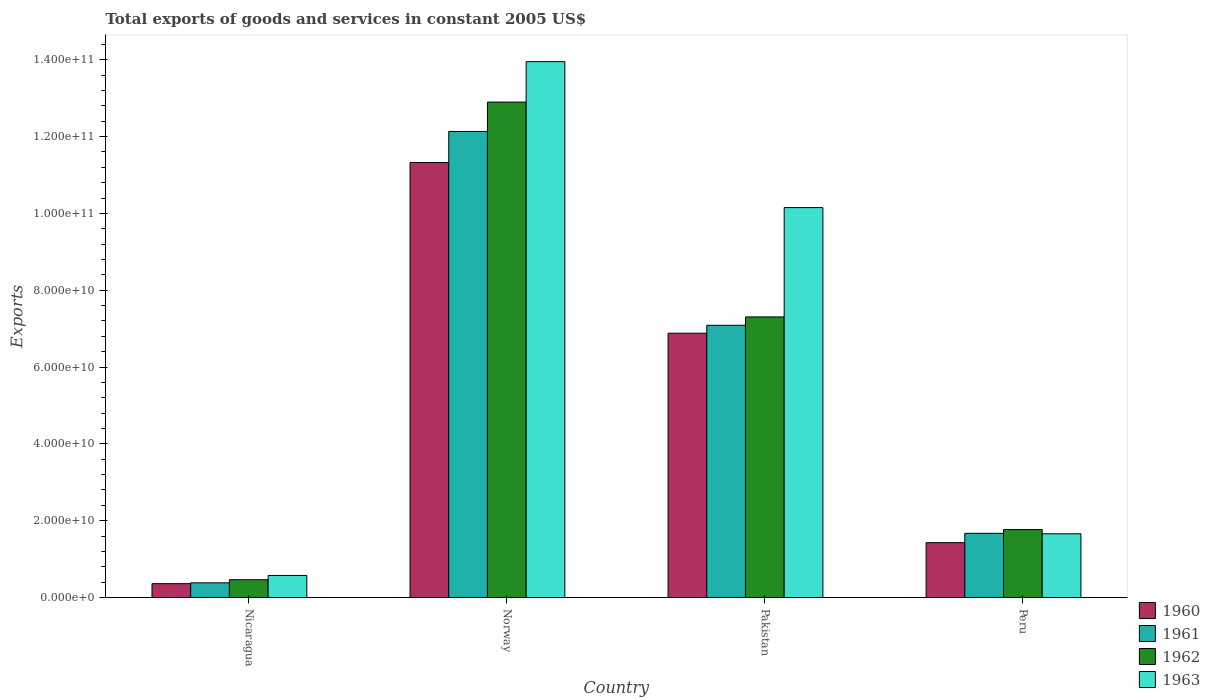How many different coloured bars are there?
Provide a succinct answer. 4. Are the number of bars on each tick of the X-axis equal?
Provide a succinct answer. Yes. How many bars are there on the 3rd tick from the left?
Offer a very short reply. 4. What is the label of the 1st group of bars from the left?
Ensure brevity in your answer.  Nicaragua. In how many cases, is the number of bars for a given country not equal to the number of legend labels?
Your response must be concise. 0. What is the total exports of goods and services in 1960 in Pakistan?
Offer a terse response. 6.88e+1. Across all countries, what is the maximum total exports of goods and services in 1960?
Offer a very short reply. 1.13e+11. Across all countries, what is the minimum total exports of goods and services in 1961?
Your answer should be very brief. 3.83e+09. In which country was the total exports of goods and services in 1963 maximum?
Your response must be concise. Norway. In which country was the total exports of goods and services in 1963 minimum?
Your answer should be compact. Nicaragua. What is the total total exports of goods and services in 1961 in the graph?
Provide a short and direct response. 2.13e+11. What is the difference between the total exports of goods and services in 1963 in Nicaragua and that in Norway?
Your answer should be compact. -1.34e+11. What is the difference between the total exports of goods and services in 1963 in Pakistan and the total exports of goods and services in 1961 in Peru?
Give a very brief answer. 8.48e+1. What is the average total exports of goods and services in 1963 per country?
Provide a short and direct response. 6.58e+1. What is the difference between the total exports of goods and services of/in 1962 and total exports of goods and services of/in 1963 in Pakistan?
Offer a very short reply. -2.85e+1. What is the ratio of the total exports of goods and services in 1960 in Norway to that in Peru?
Offer a terse response. 7.93. Is the total exports of goods and services in 1962 in Nicaragua less than that in Peru?
Provide a short and direct response. Yes. What is the difference between the highest and the second highest total exports of goods and services in 1961?
Your response must be concise. -1.05e+11. What is the difference between the highest and the lowest total exports of goods and services in 1961?
Your answer should be very brief. 1.18e+11. Is the sum of the total exports of goods and services in 1963 in Pakistan and Peru greater than the maximum total exports of goods and services in 1962 across all countries?
Ensure brevity in your answer.  No. What does the 3rd bar from the right in Peru represents?
Ensure brevity in your answer.  1961. How many bars are there?
Offer a very short reply. 16. Are all the bars in the graph horizontal?
Your response must be concise. No. What is the difference between two consecutive major ticks on the Y-axis?
Provide a short and direct response. 2.00e+1. Are the values on the major ticks of Y-axis written in scientific E-notation?
Provide a short and direct response. Yes. Does the graph contain any zero values?
Your answer should be compact. No. Where does the legend appear in the graph?
Your answer should be very brief. Bottom right. How many legend labels are there?
Give a very brief answer. 4. How are the legend labels stacked?
Offer a terse response. Vertical. What is the title of the graph?
Ensure brevity in your answer.  Total exports of goods and services in constant 2005 US$. What is the label or title of the Y-axis?
Your answer should be compact. Exports. What is the Exports of 1960 in Nicaragua?
Keep it short and to the point. 3.61e+09. What is the Exports of 1961 in Nicaragua?
Make the answer very short. 3.83e+09. What is the Exports of 1962 in Nicaragua?
Make the answer very short. 4.64e+09. What is the Exports in 1963 in Nicaragua?
Keep it short and to the point. 5.74e+09. What is the Exports of 1960 in Norway?
Provide a succinct answer. 1.13e+11. What is the Exports of 1961 in Norway?
Offer a very short reply. 1.21e+11. What is the Exports of 1962 in Norway?
Make the answer very short. 1.29e+11. What is the Exports in 1963 in Norway?
Give a very brief answer. 1.40e+11. What is the Exports in 1960 in Pakistan?
Ensure brevity in your answer.  6.88e+1. What is the Exports in 1961 in Pakistan?
Provide a succinct answer. 7.09e+1. What is the Exports of 1962 in Pakistan?
Make the answer very short. 7.31e+1. What is the Exports in 1963 in Pakistan?
Ensure brevity in your answer.  1.02e+11. What is the Exports of 1960 in Peru?
Provide a short and direct response. 1.43e+1. What is the Exports in 1961 in Peru?
Offer a very short reply. 1.67e+1. What is the Exports in 1962 in Peru?
Your answer should be very brief. 1.77e+1. What is the Exports in 1963 in Peru?
Offer a terse response. 1.66e+1. Across all countries, what is the maximum Exports in 1960?
Your response must be concise. 1.13e+11. Across all countries, what is the maximum Exports in 1961?
Offer a terse response. 1.21e+11. Across all countries, what is the maximum Exports of 1962?
Offer a very short reply. 1.29e+11. Across all countries, what is the maximum Exports of 1963?
Give a very brief answer. 1.40e+11. Across all countries, what is the minimum Exports in 1960?
Ensure brevity in your answer.  3.61e+09. Across all countries, what is the minimum Exports of 1961?
Give a very brief answer. 3.83e+09. Across all countries, what is the minimum Exports of 1962?
Your answer should be compact. 4.64e+09. Across all countries, what is the minimum Exports in 1963?
Keep it short and to the point. 5.74e+09. What is the total Exports in 1960 in the graph?
Keep it short and to the point. 2.00e+11. What is the total Exports in 1961 in the graph?
Give a very brief answer. 2.13e+11. What is the total Exports in 1962 in the graph?
Your answer should be compact. 2.24e+11. What is the total Exports of 1963 in the graph?
Your response must be concise. 2.63e+11. What is the difference between the Exports of 1960 in Nicaragua and that in Norway?
Offer a very short reply. -1.10e+11. What is the difference between the Exports in 1961 in Nicaragua and that in Norway?
Provide a succinct answer. -1.18e+11. What is the difference between the Exports in 1962 in Nicaragua and that in Norway?
Your answer should be very brief. -1.24e+11. What is the difference between the Exports in 1963 in Nicaragua and that in Norway?
Keep it short and to the point. -1.34e+11. What is the difference between the Exports in 1960 in Nicaragua and that in Pakistan?
Offer a terse response. -6.52e+1. What is the difference between the Exports in 1961 in Nicaragua and that in Pakistan?
Provide a short and direct response. -6.70e+1. What is the difference between the Exports of 1962 in Nicaragua and that in Pakistan?
Your answer should be very brief. -6.84e+1. What is the difference between the Exports in 1963 in Nicaragua and that in Pakistan?
Your answer should be very brief. -9.58e+1. What is the difference between the Exports in 1960 in Nicaragua and that in Peru?
Give a very brief answer. -1.07e+1. What is the difference between the Exports of 1961 in Nicaragua and that in Peru?
Give a very brief answer. -1.29e+1. What is the difference between the Exports of 1962 in Nicaragua and that in Peru?
Give a very brief answer. -1.31e+1. What is the difference between the Exports in 1963 in Nicaragua and that in Peru?
Your response must be concise. -1.09e+1. What is the difference between the Exports in 1960 in Norway and that in Pakistan?
Your response must be concise. 4.44e+1. What is the difference between the Exports in 1961 in Norway and that in Pakistan?
Offer a very short reply. 5.05e+1. What is the difference between the Exports of 1962 in Norway and that in Pakistan?
Offer a very short reply. 5.59e+1. What is the difference between the Exports of 1963 in Norway and that in Pakistan?
Offer a terse response. 3.80e+1. What is the difference between the Exports in 1960 in Norway and that in Peru?
Your answer should be compact. 9.90e+1. What is the difference between the Exports in 1961 in Norway and that in Peru?
Provide a succinct answer. 1.05e+11. What is the difference between the Exports of 1962 in Norway and that in Peru?
Give a very brief answer. 1.11e+11. What is the difference between the Exports of 1963 in Norway and that in Peru?
Provide a succinct answer. 1.23e+11. What is the difference between the Exports in 1960 in Pakistan and that in Peru?
Keep it short and to the point. 5.45e+1. What is the difference between the Exports of 1961 in Pakistan and that in Peru?
Your answer should be compact. 5.42e+1. What is the difference between the Exports of 1962 in Pakistan and that in Peru?
Give a very brief answer. 5.54e+1. What is the difference between the Exports of 1963 in Pakistan and that in Peru?
Give a very brief answer. 8.49e+1. What is the difference between the Exports in 1960 in Nicaragua and the Exports in 1961 in Norway?
Offer a very short reply. -1.18e+11. What is the difference between the Exports of 1960 in Nicaragua and the Exports of 1962 in Norway?
Your answer should be compact. -1.25e+11. What is the difference between the Exports of 1960 in Nicaragua and the Exports of 1963 in Norway?
Your answer should be very brief. -1.36e+11. What is the difference between the Exports in 1961 in Nicaragua and the Exports in 1962 in Norway?
Your response must be concise. -1.25e+11. What is the difference between the Exports of 1961 in Nicaragua and the Exports of 1963 in Norway?
Offer a very short reply. -1.36e+11. What is the difference between the Exports in 1962 in Nicaragua and the Exports in 1963 in Norway?
Ensure brevity in your answer.  -1.35e+11. What is the difference between the Exports of 1960 in Nicaragua and the Exports of 1961 in Pakistan?
Your response must be concise. -6.73e+1. What is the difference between the Exports of 1960 in Nicaragua and the Exports of 1962 in Pakistan?
Your answer should be compact. -6.94e+1. What is the difference between the Exports of 1960 in Nicaragua and the Exports of 1963 in Pakistan?
Provide a succinct answer. -9.79e+1. What is the difference between the Exports in 1961 in Nicaragua and the Exports in 1962 in Pakistan?
Offer a terse response. -6.92e+1. What is the difference between the Exports in 1961 in Nicaragua and the Exports in 1963 in Pakistan?
Make the answer very short. -9.77e+1. What is the difference between the Exports in 1962 in Nicaragua and the Exports in 1963 in Pakistan?
Your answer should be very brief. -9.69e+1. What is the difference between the Exports in 1960 in Nicaragua and the Exports in 1961 in Peru?
Ensure brevity in your answer.  -1.31e+1. What is the difference between the Exports in 1960 in Nicaragua and the Exports in 1962 in Peru?
Your response must be concise. -1.41e+1. What is the difference between the Exports in 1960 in Nicaragua and the Exports in 1963 in Peru?
Your response must be concise. -1.30e+1. What is the difference between the Exports in 1961 in Nicaragua and the Exports in 1962 in Peru?
Provide a succinct answer. -1.39e+1. What is the difference between the Exports of 1961 in Nicaragua and the Exports of 1963 in Peru?
Offer a very short reply. -1.28e+1. What is the difference between the Exports in 1962 in Nicaragua and the Exports in 1963 in Peru?
Offer a terse response. -1.20e+1. What is the difference between the Exports in 1960 in Norway and the Exports in 1961 in Pakistan?
Your answer should be compact. 4.24e+1. What is the difference between the Exports in 1960 in Norway and the Exports in 1962 in Pakistan?
Provide a succinct answer. 4.02e+1. What is the difference between the Exports of 1960 in Norway and the Exports of 1963 in Pakistan?
Offer a very short reply. 1.17e+1. What is the difference between the Exports in 1961 in Norway and the Exports in 1962 in Pakistan?
Your answer should be very brief. 4.83e+1. What is the difference between the Exports of 1961 in Norway and the Exports of 1963 in Pakistan?
Give a very brief answer. 1.98e+1. What is the difference between the Exports in 1962 in Norway and the Exports in 1963 in Pakistan?
Offer a very short reply. 2.75e+1. What is the difference between the Exports in 1960 in Norway and the Exports in 1961 in Peru?
Provide a succinct answer. 9.65e+1. What is the difference between the Exports of 1960 in Norway and the Exports of 1962 in Peru?
Your answer should be very brief. 9.56e+1. What is the difference between the Exports of 1960 in Norway and the Exports of 1963 in Peru?
Give a very brief answer. 9.67e+1. What is the difference between the Exports in 1961 in Norway and the Exports in 1962 in Peru?
Your response must be concise. 1.04e+11. What is the difference between the Exports in 1961 in Norway and the Exports in 1963 in Peru?
Your answer should be compact. 1.05e+11. What is the difference between the Exports of 1962 in Norway and the Exports of 1963 in Peru?
Offer a very short reply. 1.12e+11. What is the difference between the Exports in 1960 in Pakistan and the Exports in 1961 in Peru?
Your answer should be compact. 5.21e+1. What is the difference between the Exports in 1960 in Pakistan and the Exports in 1962 in Peru?
Make the answer very short. 5.11e+1. What is the difference between the Exports of 1960 in Pakistan and the Exports of 1963 in Peru?
Ensure brevity in your answer.  5.22e+1. What is the difference between the Exports in 1961 in Pakistan and the Exports in 1962 in Peru?
Ensure brevity in your answer.  5.32e+1. What is the difference between the Exports of 1961 in Pakistan and the Exports of 1963 in Peru?
Provide a succinct answer. 5.43e+1. What is the difference between the Exports in 1962 in Pakistan and the Exports in 1963 in Peru?
Offer a very short reply. 5.65e+1. What is the average Exports of 1960 per country?
Give a very brief answer. 5.00e+1. What is the average Exports in 1961 per country?
Provide a succinct answer. 5.32e+1. What is the average Exports in 1962 per country?
Your answer should be very brief. 5.61e+1. What is the average Exports of 1963 per country?
Provide a short and direct response. 6.58e+1. What is the difference between the Exports in 1960 and Exports in 1961 in Nicaragua?
Offer a very short reply. -2.16e+08. What is the difference between the Exports in 1960 and Exports in 1962 in Nicaragua?
Ensure brevity in your answer.  -1.02e+09. What is the difference between the Exports of 1960 and Exports of 1963 in Nicaragua?
Your answer should be compact. -2.13e+09. What is the difference between the Exports of 1961 and Exports of 1962 in Nicaragua?
Provide a succinct answer. -8.09e+08. What is the difference between the Exports in 1961 and Exports in 1963 in Nicaragua?
Ensure brevity in your answer.  -1.92e+09. What is the difference between the Exports in 1962 and Exports in 1963 in Nicaragua?
Provide a succinct answer. -1.11e+09. What is the difference between the Exports of 1960 and Exports of 1961 in Norway?
Ensure brevity in your answer.  -8.08e+09. What is the difference between the Exports in 1960 and Exports in 1962 in Norway?
Offer a terse response. -1.57e+1. What is the difference between the Exports of 1960 and Exports of 1963 in Norway?
Your answer should be very brief. -2.63e+1. What is the difference between the Exports of 1961 and Exports of 1962 in Norway?
Offer a very short reply. -7.65e+09. What is the difference between the Exports of 1961 and Exports of 1963 in Norway?
Offer a terse response. -1.82e+1. What is the difference between the Exports in 1962 and Exports in 1963 in Norway?
Your answer should be compact. -1.05e+1. What is the difference between the Exports in 1960 and Exports in 1961 in Pakistan?
Provide a succinct answer. -2.06e+09. What is the difference between the Exports in 1960 and Exports in 1962 in Pakistan?
Your response must be concise. -4.24e+09. What is the difference between the Exports in 1960 and Exports in 1963 in Pakistan?
Your answer should be compact. -3.27e+1. What is the difference between the Exports in 1961 and Exports in 1962 in Pakistan?
Keep it short and to the point. -2.18e+09. What is the difference between the Exports of 1961 and Exports of 1963 in Pakistan?
Keep it short and to the point. -3.06e+1. What is the difference between the Exports of 1962 and Exports of 1963 in Pakistan?
Offer a very short reply. -2.85e+1. What is the difference between the Exports in 1960 and Exports in 1961 in Peru?
Keep it short and to the point. -2.43e+09. What is the difference between the Exports in 1960 and Exports in 1962 in Peru?
Offer a very short reply. -3.42e+09. What is the difference between the Exports of 1960 and Exports of 1963 in Peru?
Make the answer very short. -2.32e+09. What is the difference between the Exports of 1961 and Exports of 1962 in Peru?
Your answer should be compact. -9.83e+08. What is the difference between the Exports in 1961 and Exports in 1963 in Peru?
Your answer should be very brief. 1.16e+08. What is the difference between the Exports in 1962 and Exports in 1963 in Peru?
Provide a short and direct response. 1.10e+09. What is the ratio of the Exports in 1960 in Nicaragua to that in Norway?
Provide a short and direct response. 0.03. What is the ratio of the Exports of 1961 in Nicaragua to that in Norway?
Make the answer very short. 0.03. What is the ratio of the Exports of 1962 in Nicaragua to that in Norway?
Provide a succinct answer. 0.04. What is the ratio of the Exports of 1963 in Nicaragua to that in Norway?
Keep it short and to the point. 0.04. What is the ratio of the Exports of 1960 in Nicaragua to that in Pakistan?
Make the answer very short. 0.05. What is the ratio of the Exports of 1961 in Nicaragua to that in Pakistan?
Ensure brevity in your answer.  0.05. What is the ratio of the Exports of 1962 in Nicaragua to that in Pakistan?
Give a very brief answer. 0.06. What is the ratio of the Exports in 1963 in Nicaragua to that in Pakistan?
Keep it short and to the point. 0.06. What is the ratio of the Exports in 1960 in Nicaragua to that in Peru?
Offer a very short reply. 0.25. What is the ratio of the Exports of 1961 in Nicaragua to that in Peru?
Offer a very short reply. 0.23. What is the ratio of the Exports in 1962 in Nicaragua to that in Peru?
Offer a terse response. 0.26. What is the ratio of the Exports of 1963 in Nicaragua to that in Peru?
Ensure brevity in your answer.  0.35. What is the ratio of the Exports of 1960 in Norway to that in Pakistan?
Your answer should be very brief. 1.65. What is the ratio of the Exports in 1961 in Norway to that in Pakistan?
Ensure brevity in your answer.  1.71. What is the ratio of the Exports in 1962 in Norway to that in Pakistan?
Offer a terse response. 1.77. What is the ratio of the Exports in 1963 in Norway to that in Pakistan?
Give a very brief answer. 1.37. What is the ratio of the Exports of 1960 in Norway to that in Peru?
Your response must be concise. 7.93. What is the ratio of the Exports in 1961 in Norway to that in Peru?
Make the answer very short. 7.26. What is the ratio of the Exports in 1962 in Norway to that in Peru?
Make the answer very short. 7.29. What is the ratio of the Exports of 1963 in Norway to that in Peru?
Provide a succinct answer. 8.41. What is the ratio of the Exports of 1960 in Pakistan to that in Peru?
Keep it short and to the point. 4.82. What is the ratio of the Exports in 1961 in Pakistan to that in Peru?
Your answer should be compact. 4.24. What is the ratio of the Exports of 1962 in Pakistan to that in Peru?
Give a very brief answer. 4.13. What is the ratio of the Exports of 1963 in Pakistan to that in Peru?
Provide a succinct answer. 6.12. What is the difference between the highest and the second highest Exports of 1960?
Provide a short and direct response. 4.44e+1. What is the difference between the highest and the second highest Exports of 1961?
Ensure brevity in your answer.  5.05e+1. What is the difference between the highest and the second highest Exports of 1962?
Your answer should be compact. 5.59e+1. What is the difference between the highest and the second highest Exports in 1963?
Offer a terse response. 3.80e+1. What is the difference between the highest and the lowest Exports of 1960?
Make the answer very short. 1.10e+11. What is the difference between the highest and the lowest Exports of 1961?
Your response must be concise. 1.18e+11. What is the difference between the highest and the lowest Exports of 1962?
Your answer should be very brief. 1.24e+11. What is the difference between the highest and the lowest Exports of 1963?
Ensure brevity in your answer.  1.34e+11. 